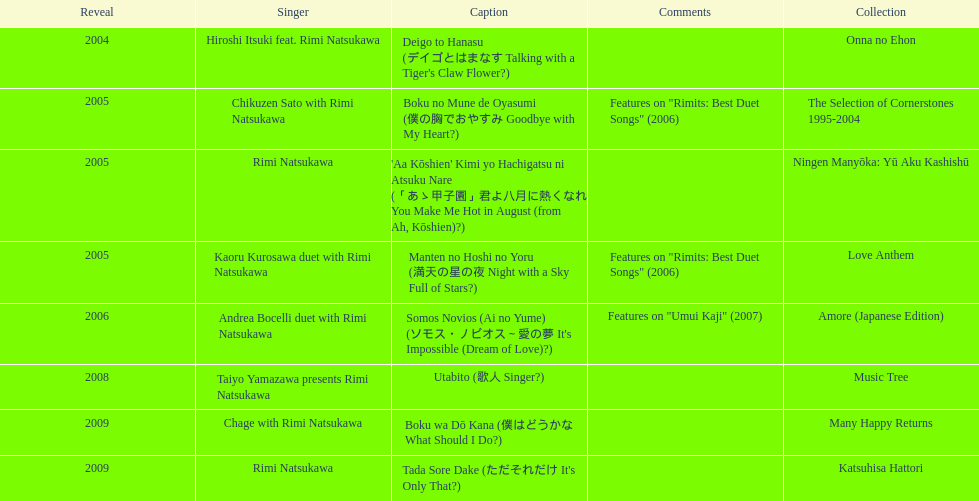What year was the first title released? 2004. 